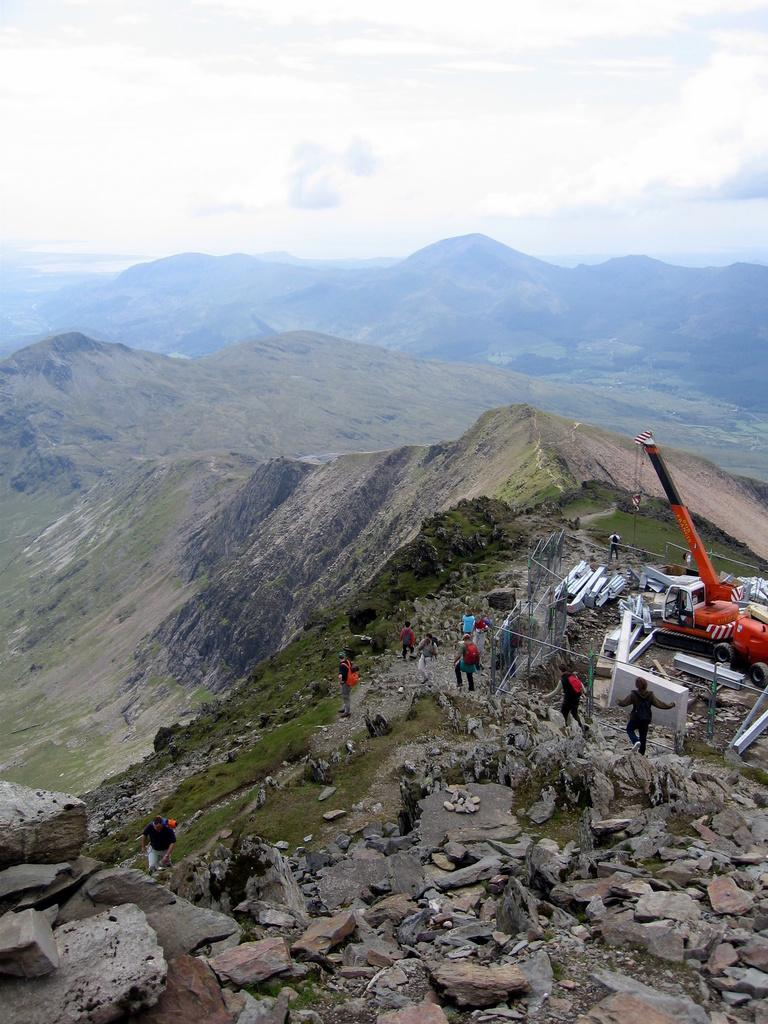What are the people in the image doing? The people in the image are standing on the hills. What type of machinery can be seen in the image? There is a crane visible in the image. What type of natural formation is present in the image? Rocks are present in the image. What is the main landscape feature in the image? The hills are visible in the image. What is visible in the background of the image? The sky is visible in the background of the image. What can be seen in the sky? Clouds are present in the sky. Where is the goat located in the image? There is no goat present in the image. What type of flag is being raised on the hill in the image? There is no flag present in the image. 